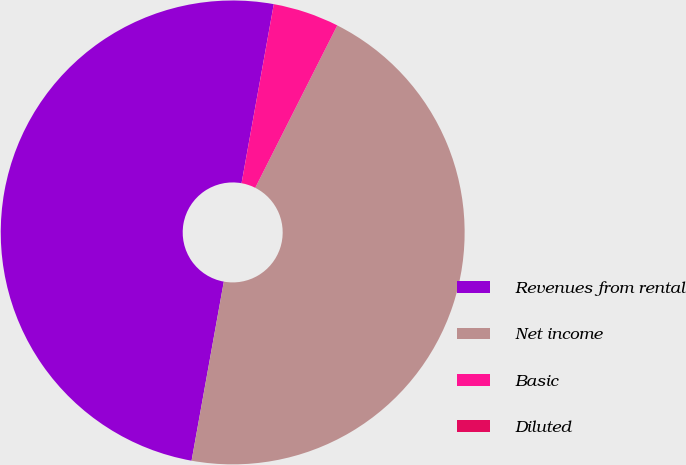Convert chart to OTSL. <chart><loc_0><loc_0><loc_500><loc_500><pie_chart><fcel>Revenues from rental<fcel>Net income<fcel>Basic<fcel>Diluted<nl><fcel>50.0%<fcel>45.39%<fcel>4.61%<fcel>0.0%<nl></chart> 